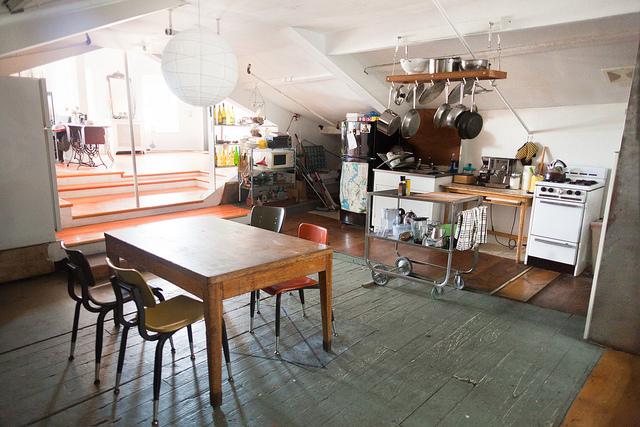What style of decorating is presented in this room?
Concise answer only. Contemporary. How many chairs do you see?
Quick response, please. 4. How many chairs are there?
Keep it brief. 4. What room is this?
Write a very short answer. Kitchen. 